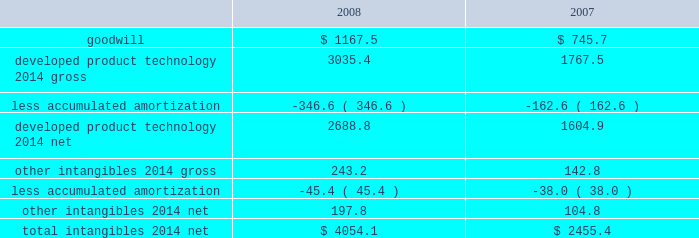On the underlying exposure .
For derivative contracts that are designated and qualify as cash fl ow hedges , the effective portion of gains and losses on these contracts is reported as a component of other comprehensive income and reclassifi ed into earnings in the same period the hedged transaction affects earnings .
Hedge ineffectiveness is immediately recognized in earnings .
Derivative contracts that are not designated as hedging instruments are recorded at fair value with the gain or loss recognized in current earnings during the period of change .
We may enter into foreign currency forward and option contracts to reduce the effect of fl uctuating currency exchange rates ( principally the euro , the british pound , and the japanese yen ) .
Foreign currency derivatives used for hedging are put in place using the same or like currencies and duration as the underlying exposures .
Forward contracts are principally used to manage exposures arising from subsidiary trade and loan payables and receivables denominated in foreign currencies .
These contracts are recorded at fair value with the gain or loss recognized in other 2014net .
The purchased option contracts are used to hedge anticipated foreign currency transactions , primarily intercompany inventory activities expected to occur within the next year .
These contracts are designated as cash fl ow hedges of those future transactions and the impact on earnings is included in cost of sales .
We may enter into foreign currency forward contracts and currency swaps as fair value hedges of fi rm commitments .
Forward and option contracts generally have maturities not exceeding 12 months .
In the normal course of business , our operations are exposed to fl uctuations in interest rates .
These fl uctuations can vary the costs of fi nancing , investing , and operating .
We address a portion of these risks through a controlled program of risk management that includes the use of derivative fi nancial instruments .
The objective of controlling these risks is to limit the impact of fl uctuations in interest rates on earnings .
Our primary interest rate risk exposure results from changes in short-term u.s .
Dollar interest rates .
In an effort to manage interest rate exposures , we strive to achieve an acceptable balance between fi xed and fl oating rate debt and investment positions and may enter into interest rate swaps or collars to help maintain that balance .
Interest rate swaps or collars that convert our fi xed- rate debt or investments to a fl oating rate are designated as fair value hedges of the underlying instruments .
Interest rate swaps or collars that convert fl oating rate debt or investments to a fi xed rate are designated as cash fl ow hedg- es .
Interest expense on the debt is adjusted to include the payments made or received under the swap agreements .
Goodwill and other intangibles : goodwill is not amortized .
All other intangibles arising from acquisitions and research alliances have fi nite lives and are amortized over their estimated useful lives , ranging from 5 to 20 years , using the straight-line method .
The weighted-average amortization period for developed product technology is approximately 12 years .
Amortization expense for 2008 , 2007 , and 2006 was $ 193.4 million , $ 172.8 million , and $ 7.6 million before tax , respectively .
The estimated amortization expense for each of the fi ve succeeding years approximates $ 280 million before tax , per year .
Substantially all of the amortization expense is included in cost of sales .
See note 3 for further discussion of goodwill and other intangibles acquired in 2008 and 2007 .
Goodwill and other intangible assets at december 31 were as follows: .
Goodwill and net other intangibles are reviewed to assess recoverability at least annually and when certain impairment indicators are present .
No signifi cant impairments occurred with respect to the carrying value of our goodwill or other intangible assets in 2008 , 2007 , or 2006 .
Property and equipment : property and equipment is stated on the basis of cost .
Provisions for depreciation of buildings and equipment are computed generally by the straight-line method at rates based on their estimated useful lives ( 12 to 50 years for buildings and 3 to 18 years for equipment ) .
We review the carrying value of long-lived assets for potential impairment on a periodic basis and whenever events or changes in circumstances indicate the .
What was the percent of growth or decline in the total intangibles 2014 net from 2007 to 2008? 
Computations: ((4054.1 - 2455.4) / 2455.4)
Answer: 0.6511. 